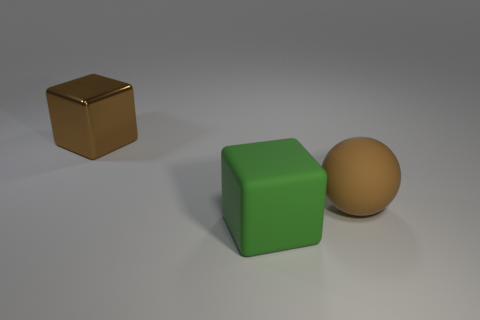Add 1 tiny purple shiny spheres. How many objects exist? 4 Subtract all blocks. How many objects are left? 1 Add 3 big rubber things. How many big rubber things are left? 5 Add 2 big brown metallic cubes. How many big brown metallic cubes exist? 3 Subtract 0 brown cylinders. How many objects are left? 3 Subtract all green matte objects. Subtract all tiny red rubber cubes. How many objects are left? 2 